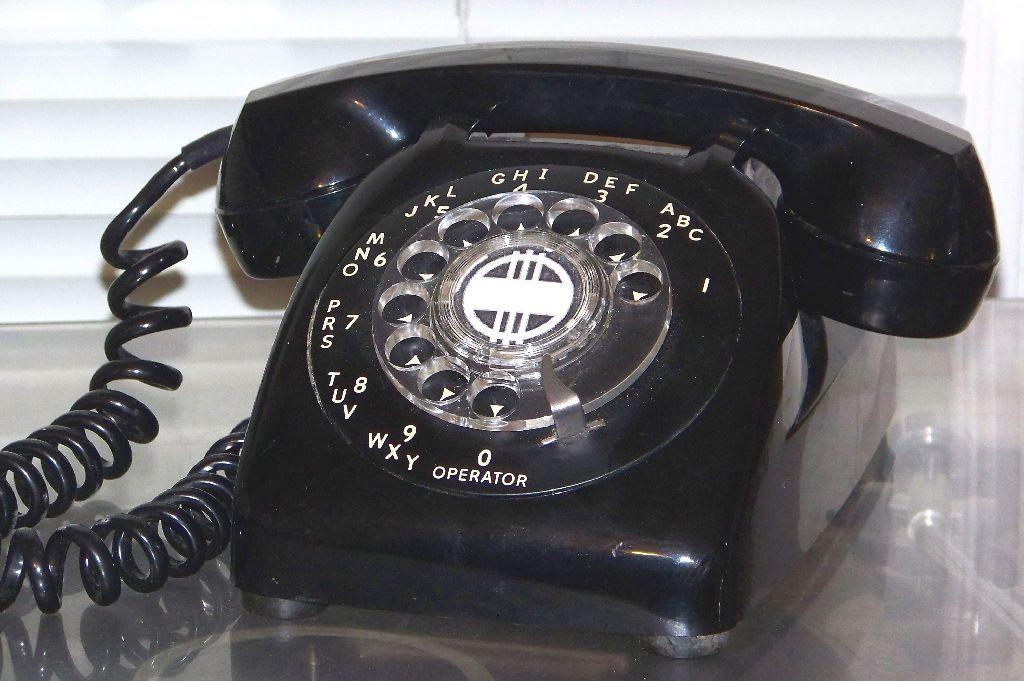What object is present in the image? There is a telephone in the image. What is the telephone placed on? The telephone is on a glass surface. What can be seen in the background of the image? There is a wall visible in the background of the image. What type of texture does the ladybug have in the image? There is no ladybug present in the image. 